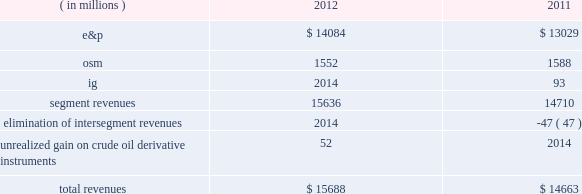Key operating and financial activities significant operating and financial activities during 2012 include : 2022 net proved reserve additions for the e&p and osm segments combined of 389 mmboe , for a 226 percent reserve replacement 2022 increased proved liquid hydrocarbon and synthetic crude oil reserves by 316 mmbbls , for a reserve replacement of 268 percent for these commodities 2022 recorded more than 95 percent average operational availability for operated e&p assets 2022 increased e&p net sales volumes , excluding libya , by 8 percent 2022 eagle ford shale average net sales volumes of 65 mboed for december 2012 , a fourfold increase over december 2011 2022 bakken shale average net sales volumes of 29 mboed , a 71 percent increase over last year 2022 resumed sales from libya and reached pre-conflict production levels 2022 international liquid hydrocarbon sales volumes , for which average realizations have exceeded wti , were 62 percent of net e&p liquid hydrocarbon sales 2022 closed $ 1 billion of acquisitions in the core of the eagle ford shale 2022 assumed operatorship of the vilje field located offshore norway 2022 signed agreements for new exploration positions in e.g. , gabon , kenya and ethiopia 2022 issued $ 1 billion of 3-year senior notes at 0.9 percent interest and $ 1 billion of 10-year senior notes at 2.8 percent interest some significant 2013 activities through february 22 , 2013 include : 2022 closed sale of our alaska assets in january 2013 2022 closed sale of our interest in the neptune gas plant in february 2013 consolidated results of operations : 2012 compared to 2011 consolidated income before income taxes was 38 percent higher in 2012 than consolidated income from continuing operations before income taxes were in 2011 , largely due to higher liquid hydrocarbon sales volumes in our e&p segment , partially offset by lower earnings from our osm and ig segments .
The 7 percent decrease in income from continuing operations included lower earnings in the u.k .
And e.g. , partially offset by higher earnings in libya .
Also , in 2011 we were not in an excess foreign tax credit position for the entire year as we were in 2012 .
The effective income tax rate for continuing operations was 74 percent in 2012 compared to 61 percent in 2011 .
Revenues are summarized in the table: .
E&p segment revenues increased $ 1055 million from 2011 to 2012 , primarily due to higher average liquid hydrocarbon sales volumes .
E&p segment revenues included a net realized gain on crude oil derivative instruments of $ 15 million in 2012 while the impact of derivatives was not significant in 2011 .
See item 8 .
Financial statements and supplementary data 2013 note 16 to the consolidated financial statement for more information about our crude oil derivative instruments .
Included in our e&p segment are supply optimization activities which include the purchase of commodities from third parties for resale .
See the cost of revenues discussion as revenues from supply optimization approximate the related costs .
Supply optimization serves to aggregate volumes in order to satisfy transportation commitments and to achieve flexibility within product .
What were total segment revenues for 2012 and 2011 in millions? 
Computations: (15636 + 14710)
Answer: 30346.0. 